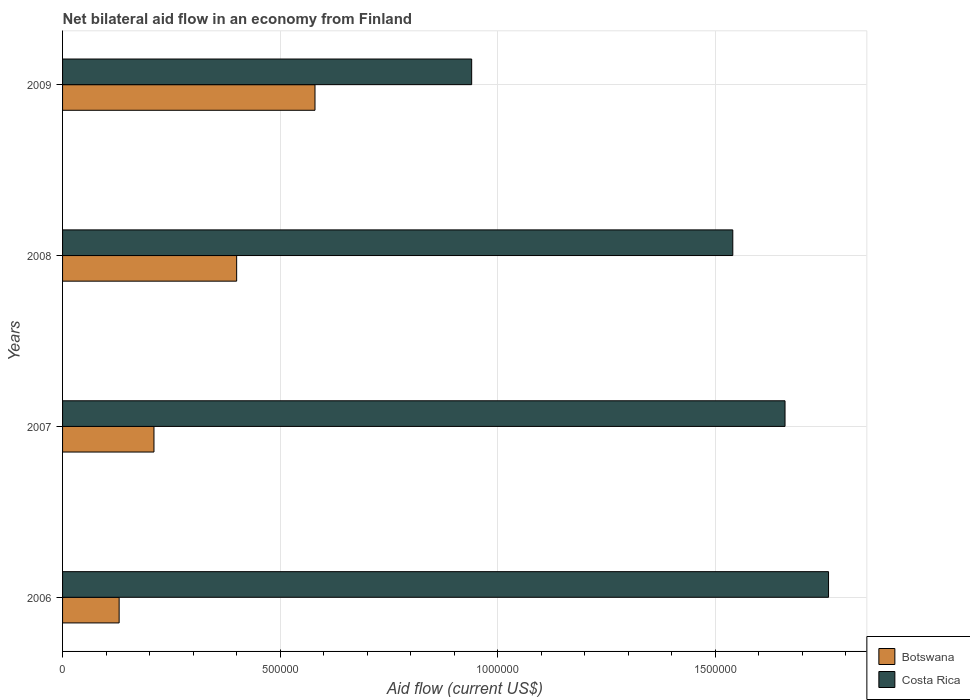How many groups of bars are there?
Give a very brief answer. 4. Are the number of bars per tick equal to the number of legend labels?
Offer a very short reply. Yes. How many bars are there on the 2nd tick from the bottom?
Give a very brief answer. 2. What is the label of the 3rd group of bars from the top?
Keep it short and to the point. 2007. What is the net bilateral aid flow in Botswana in 2009?
Provide a short and direct response. 5.80e+05. Across all years, what is the maximum net bilateral aid flow in Costa Rica?
Your answer should be very brief. 1.76e+06. What is the total net bilateral aid flow in Botswana in the graph?
Keep it short and to the point. 1.32e+06. What is the difference between the net bilateral aid flow in Costa Rica in 2006 and the net bilateral aid flow in Botswana in 2009?
Give a very brief answer. 1.18e+06. What is the average net bilateral aid flow in Costa Rica per year?
Your answer should be very brief. 1.48e+06. In the year 2006, what is the difference between the net bilateral aid flow in Costa Rica and net bilateral aid flow in Botswana?
Give a very brief answer. 1.63e+06. In how many years, is the net bilateral aid flow in Botswana greater than 1300000 US$?
Your answer should be compact. 0. What is the ratio of the net bilateral aid flow in Botswana in 2006 to that in 2008?
Your answer should be very brief. 0.33. What is the difference between the highest and the second highest net bilateral aid flow in Botswana?
Ensure brevity in your answer.  1.80e+05. What is the difference between the highest and the lowest net bilateral aid flow in Costa Rica?
Make the answer very short. 8.20e+05. In how many years, is the net bilateral aid flow in Costa Rica greater than the average net bilateral aid flow in Costa Rica taken over all years?
Provide a succinct answer. 3. Is the sum of the net bilateral aid flow in Botswana in 2007 and 2008 greater than the maximum net bilateral aid flow in Costa Rica across all years?
Your response must be concise. No. Are all the bars in the graph horizontal?
Keep it short and to the point. Yes. How many years are there in the graph?
Provide a succinct answer. 4. What is the difference between two consecutive major ticks on the X-axis?
Provide a short and direct response. 5.00e+05. How many legend labels are there?
Offer a terse response. 2. How are the legend labels stacked?
Offer a very short reply. Vertical. What is the title of the graph?
Give a very brief answer. Net bilateral aid flow in an economy from Finland. What is the label or title of the Y-axis?
Your response must be concise. Years. What is the Aid flow (current US$) in Costa Rica in 2006?
Provide a short and direct response. 1.76e+06. What is the Aid flow (current US$) of Botswana in 2007?
Your response must be concise. 2.10e+05. What is the Aid flow (current US$) in Costa Rica in 2007?
Make the answer very short. 1.66e+06. What is the Aid flow (current US$) of Costa Rica in 2008?
Keep it short and to the point. 1.54e+06. What is the Aid flow (current US$) of Botswana in 2009?
Your response must be concise. 5.80e+05. What is the Aid flow (current US$) in Costa Rica in 2009?
Provide a short and direct response. 9.40e+05. Across all years, what is the maximum Aid flow (current US$) in Botswana?
Your answer should be very brief. 5.80e+05. Across all years, what is the maximum Aid flow (current US$) of Costa Rica?
Give a very brief answer. 1.76e+06. Across all years, what is the minimum Aid flow (current US$) in Costa Rica?
Make the answer very short. 9.40e+05. What is the total Aid flow (current US$) in Botswana in the graph?
Provide a succinct answer. 1.32e+06. What is the total Aid flow (current US$) of Costa Rica in the graph?
Offer a terse response. 5.90e+06. What is the difference between the Aid flow (current US$) in Botswana in 2006 and that in 2007?
Your answer should be compact. -8.00e+04. What is the difference between the Aid flow (current US$) in Costa Rica in 2006 and that in 2008?
Give a very brief answer. 2.20e+05. What is the difference between the Aid flow (current US$) of Botswana in 2006 and that in 2009?
Make the answer very short. -4.50e+05. What is the difference between the Aid flow (current US$) of Costa Rica in 2006 and that in 2009?
Provide a succinct answer. 8.20e+05. What is the difference between the Aid flow (current US$) of Botswana in 2007 and that in 2008?
Offer a terse response. -1.90e+05. What is the difference between the Aid flow (current US$) in Botswana in 2007 and that in 2009?
Provide a succinct answer. -3.70e+05. What is the difference between the Aid flow (current US$) of Costa Rica in 2007 and that in 2009?
Give a very brief answer. 7.20e+05. What is the difference between the Aid flow (current US$) in Botswana in 2008 and that in 2009?
Offer a terse response. -1.80e+05. What is the difference between the Aid flow (current US$) of Botswana in 2006 and the Aid flow (current US$) of Costa Rica in 2007?
Your answer should be very brief. -1.53e+06. What is the difference between the Aid flow (current US$) of Botswana in 2006 and the Aid flow (current US$) of Costa Rica in 2008?
Your response must be concise. -1.41e+06. What is the difference between the Aid flow (current US$) in Botswana in 2006 and the Aid flow (current US$) in Costa Rica in 2009?
Your answer should be very brief. -8.10e+05. What is the difference between the Aid flow (current US$) of Botswana in 2007 and the Aid flow (current US$) of Costa Rica in 2008?
Ensure brevity in your answer.  -1.33e+06. What is the difference between the Aid flow (current US$) of Botswana in 2007 and the Aid flow (current US$) of Costa Rica in 2009?
Your answer should be compact. -7.30e+05. What is the difference between the Aid flow (current US$) in Botswana in 2008 and the Aid flow (current US$) in Costa Rica in 2009?
Ensure brevity in your answer.  -5.40e+05. What is the average Aid flow (current US$) in Costa Rica per year?
Provide a succinct answer. 1.48e+06. In the year 2006, what is the difference between the Aid flow (current US$) in Botswana and Aid flow (current US$) in Costa Rica?
Keep it short and to the point. -1.63e+06. In the year 2007, what is the difference between the Aid flow (current US$) in Botswana and Aid flow (current US$) in Costa Rica?
Your response must be concise. -1.45e+06. In the year 2008, what is the difference between the Aid flow (current US$) of Botswana and Aid flow (current US$) of Costa Rica?
Offer a terse response. -1.14e+06. In the year 2009, what is the difference between the Aid flow (current US$) in Botswana and Aid flow (current US$) in Costa Rica?
Offer a terse response. -3.60e+05. What is the ratio of the Aid flow (current US$) in Botswana in 2006 to that in 2007?
Ensure brevity in your answer.  0.62. What is the ratio of the Aid flow (current US$) in Costa Rica in 2006 to that in 2007?
Offer a very short reply. 1.06. What is the ratio of the Aid flow (current US$) in Botswana in 2006 to that in 2008?
Your response must be concise. 0.33. What is the ratio of the Aid flow (current US$) of Costa Rica in 2006 to that in 2008?
Provide a succinct answer. 1.14. What is the ratio of the Aid flow (current US$) in Botswana in 2006 to that in 2009?
Give a very brief answer. 0.22. What is the ratio of the Aid flow (current US$) in Costa Rica in 2006 to that in 2009?
Provide a succinct answer. 1.87. What is the ratio of the Aid flow (current US$) in Botswana in 2007 to that in 2008?
Your answer should be compact. 0.53. What is the ratio of the Aid flow (current US$) of Costa Rica in 2007 to that in 2008?
Your answer should be very brief. 1.08. What is the ratio of the Aid flow (current US$) in Botswana in 2007 to that in 2009?
Your response must be concise. 0.36. What is the ratio of the Aid flow (current US$) in Costa Rica in 2007 to that in 2009?
Offer a very short reply. 1.77. What is the ratio of the Aid flow (current US$) in Botswana in 2008 to that in 2009?
Your response must be concise. 0.69. What is the ratio of the Aid flow (current US$) in Costa Rica in 2008 to that in 2009?
Provide a succinct answer. 1.64. What is the difference between the highest and the second highest Aid flow (current US$) in Botswana?
Keep it short and to the point. 1.80e+05. What is the difference between the highest and the second highest Aid flow (current US$) of Costa Rica?
Offer a very short reply. 1.00e+05. What is the difference between the highest and the lowest Aid flow (current US$) in Costa Rica?
Keep it short and to the point. 8.20e+05. 